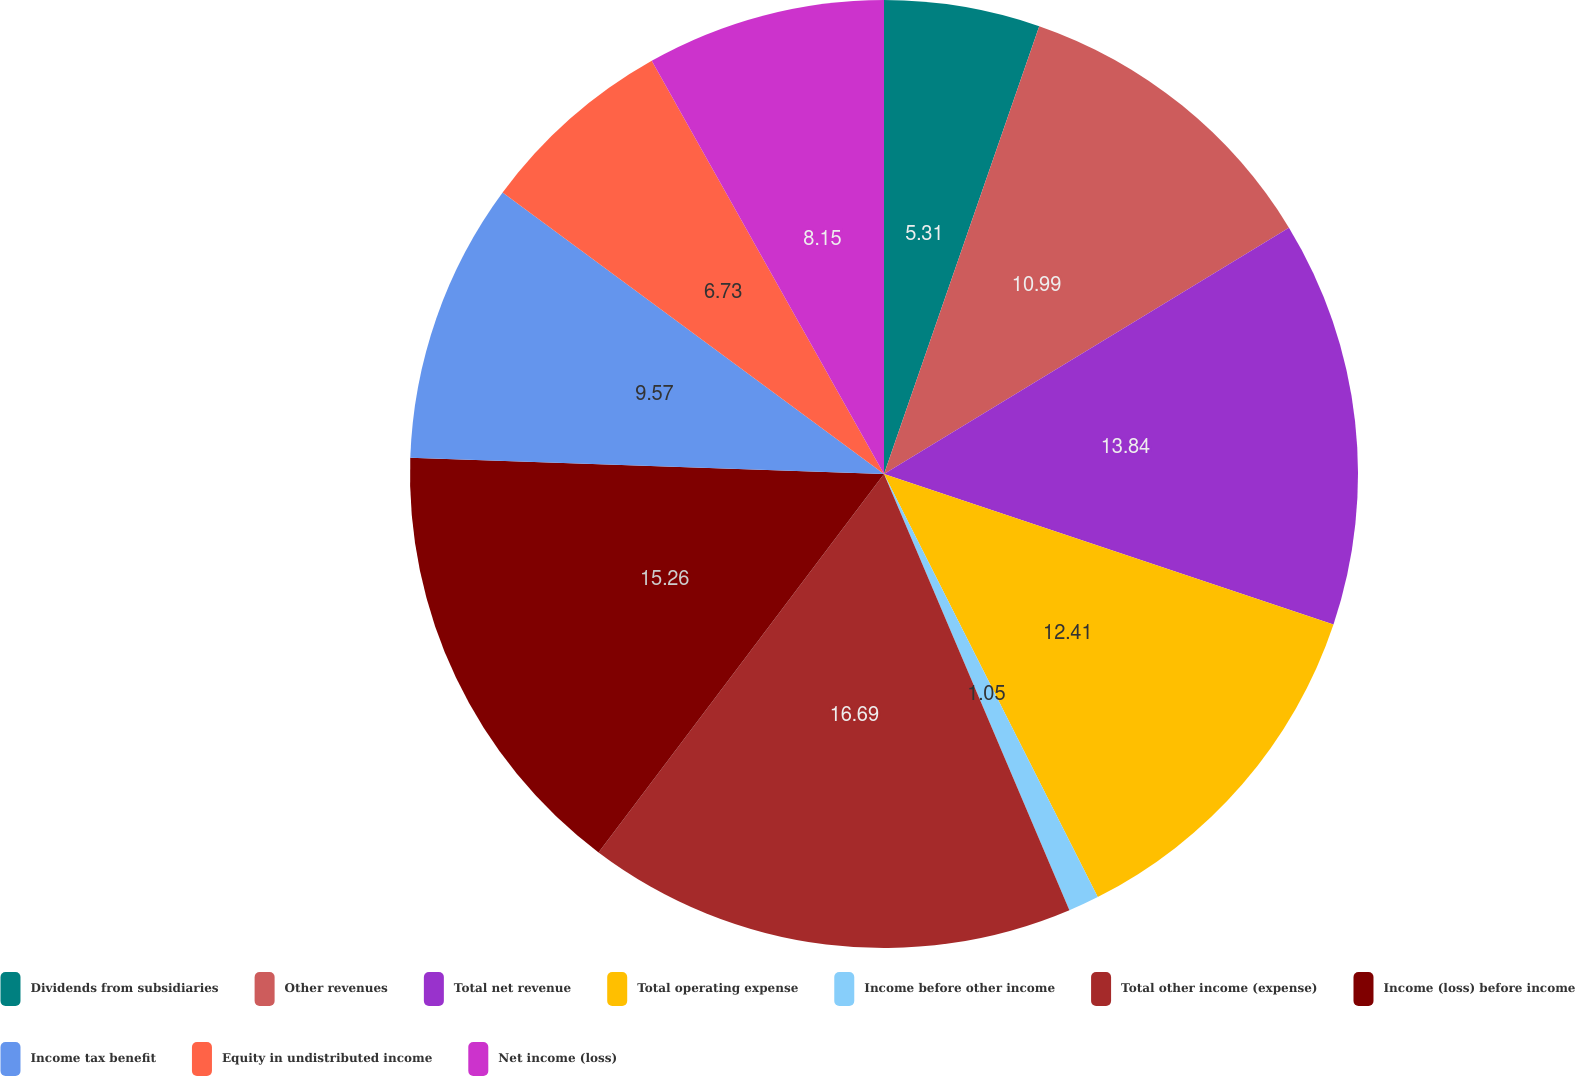Convert chart to OTSL. <chart><loc_0><loc_0><loc_500><loc_500><pie_chart><fcel>Dividends from subsidiaries<fcel>Other revenues<fcel>Total net revenue<fcel>Total operating expense<fcel>Income before other income<fcel>Total other income (expense)<fcel>Income (loss) before income<fcel>Income tax benefit<fcel>Equity in undistributed income<fcel>Net income (loss)<nl><fcel>5.31%<fcel>10.99%<fcel>13.84%<fcel>12.41%<fcel>1.05%<fcel>16.68%<fcel>15.26%<fcel>9.57%<fcel>6.73%<fcel>8.15%<nl></chart> 